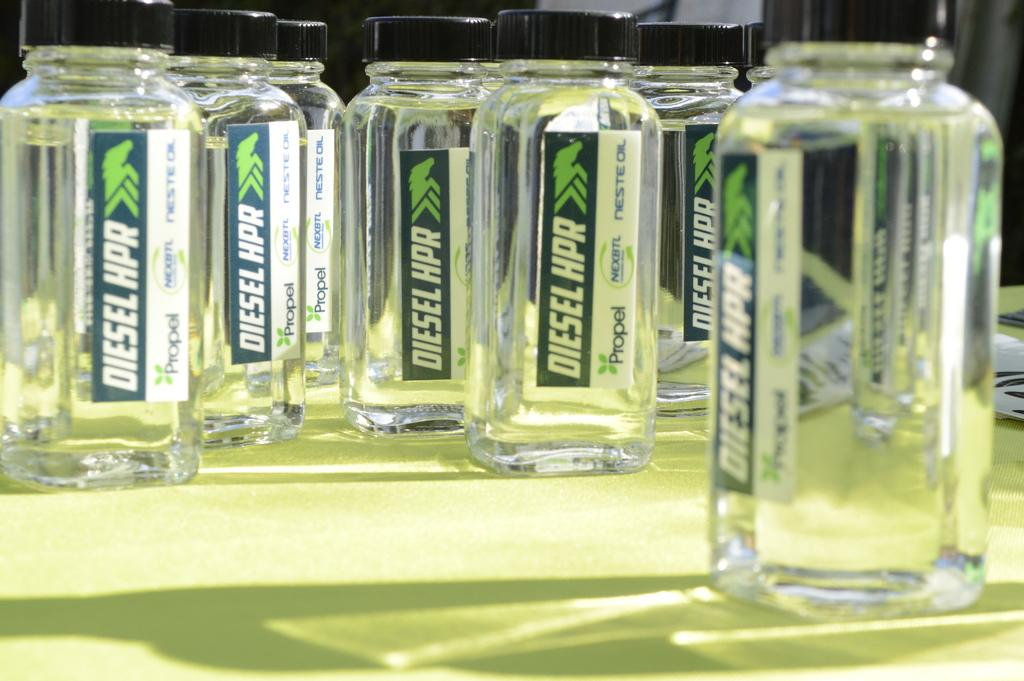<image>
Render a clear and concise summary of the photo. Multiple bottles labeled Diesel HPR with clear liquid in them. 